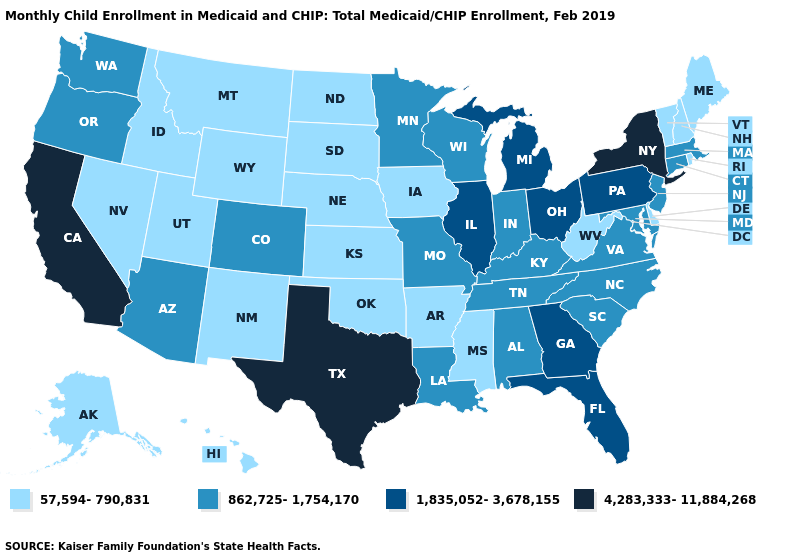What is the lowest value in states that border Illinois?
Give a very brief answer. 57,594-790,831. Does California have the lowest value in the USA?
Answer briefly. No. Which states hav the highest value in the West?
Answer briefly. California. Does California have the highest value in the West?
Concise answer only. Yes. Does Alaska have the lowest value in the West?
Write a very short answer. Yes. Does West Virginia have the same value as New Mexico?
Give a very brief answer. Yes. What is the value of Wyoming?
Give a very brief answer. 57,594-790,831. Name the states that have a value in the range 1,835,052-3,678,155?
Concise answer only. Florida, Georgia, Illinois, Michigan, Ohio, Pennsylvania. Does Oregon have a higher value than Texas?
Be succinct. No. What is the highest value in the USA?
Write a very short answer. 4,283,333-11,884,268. Among the states that border Nevada , does Utah have the highest value?
Be succinct. No. Does the map have missing data?
Be succinct. No. What is the value of Montana?
Keep it brief. 57,594-790,831. What is the lowest value in the USA?
Short answer required. 57,594-790,831. What is the lowest value in states that border North Carolina?
Short answer required. 862,725-1,754,170. 